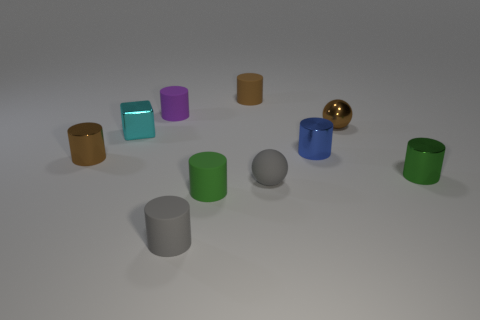Subtract all blue cylinders. How many cylinders are left? 6 Subtract all brown cylinders. How many cylinders are left? 5 Subtract 2 balls. How many balls are left? 0 Add 5 rubber cylinders. How many rubber cylinders exist? 9 Subtract 0 red blocks. How many objects are left? 10 Subtract all cylinders. How many objects are left? 3 Subtract all cyan balls. Subtract all gray cubes. How many balls are left? 2 Subtract all blue cubes. How many purple balls are left? 0 Subtract all shiny spheres. Subtract all big blocks. How many objects are left? 9 Add 2 brown cylinders. How many brown cylinders are left? 4 